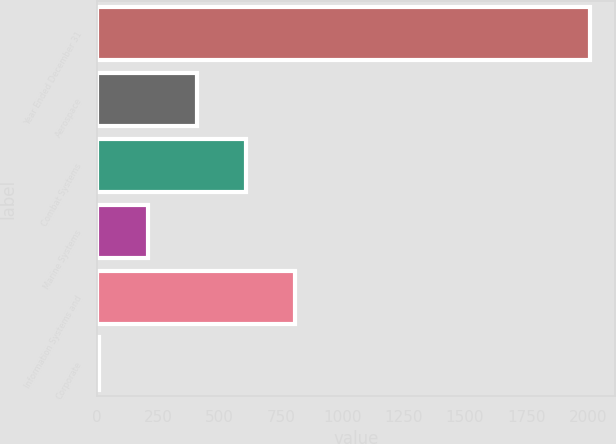<chart> <loc_0><loc_0><loc_500><loc_500><bar_chart><fcel>Year Ended December 31<fcel>Aerospace<fcel>Combat Systems<fcel>Marine Systems<fcel>Information Systems and<fcel>Corporate<nl><fcel>2010<fcel>407.6<fcel>607.9<fcel>207.3<fcel>808.2<fcel>7<nl></chart> 